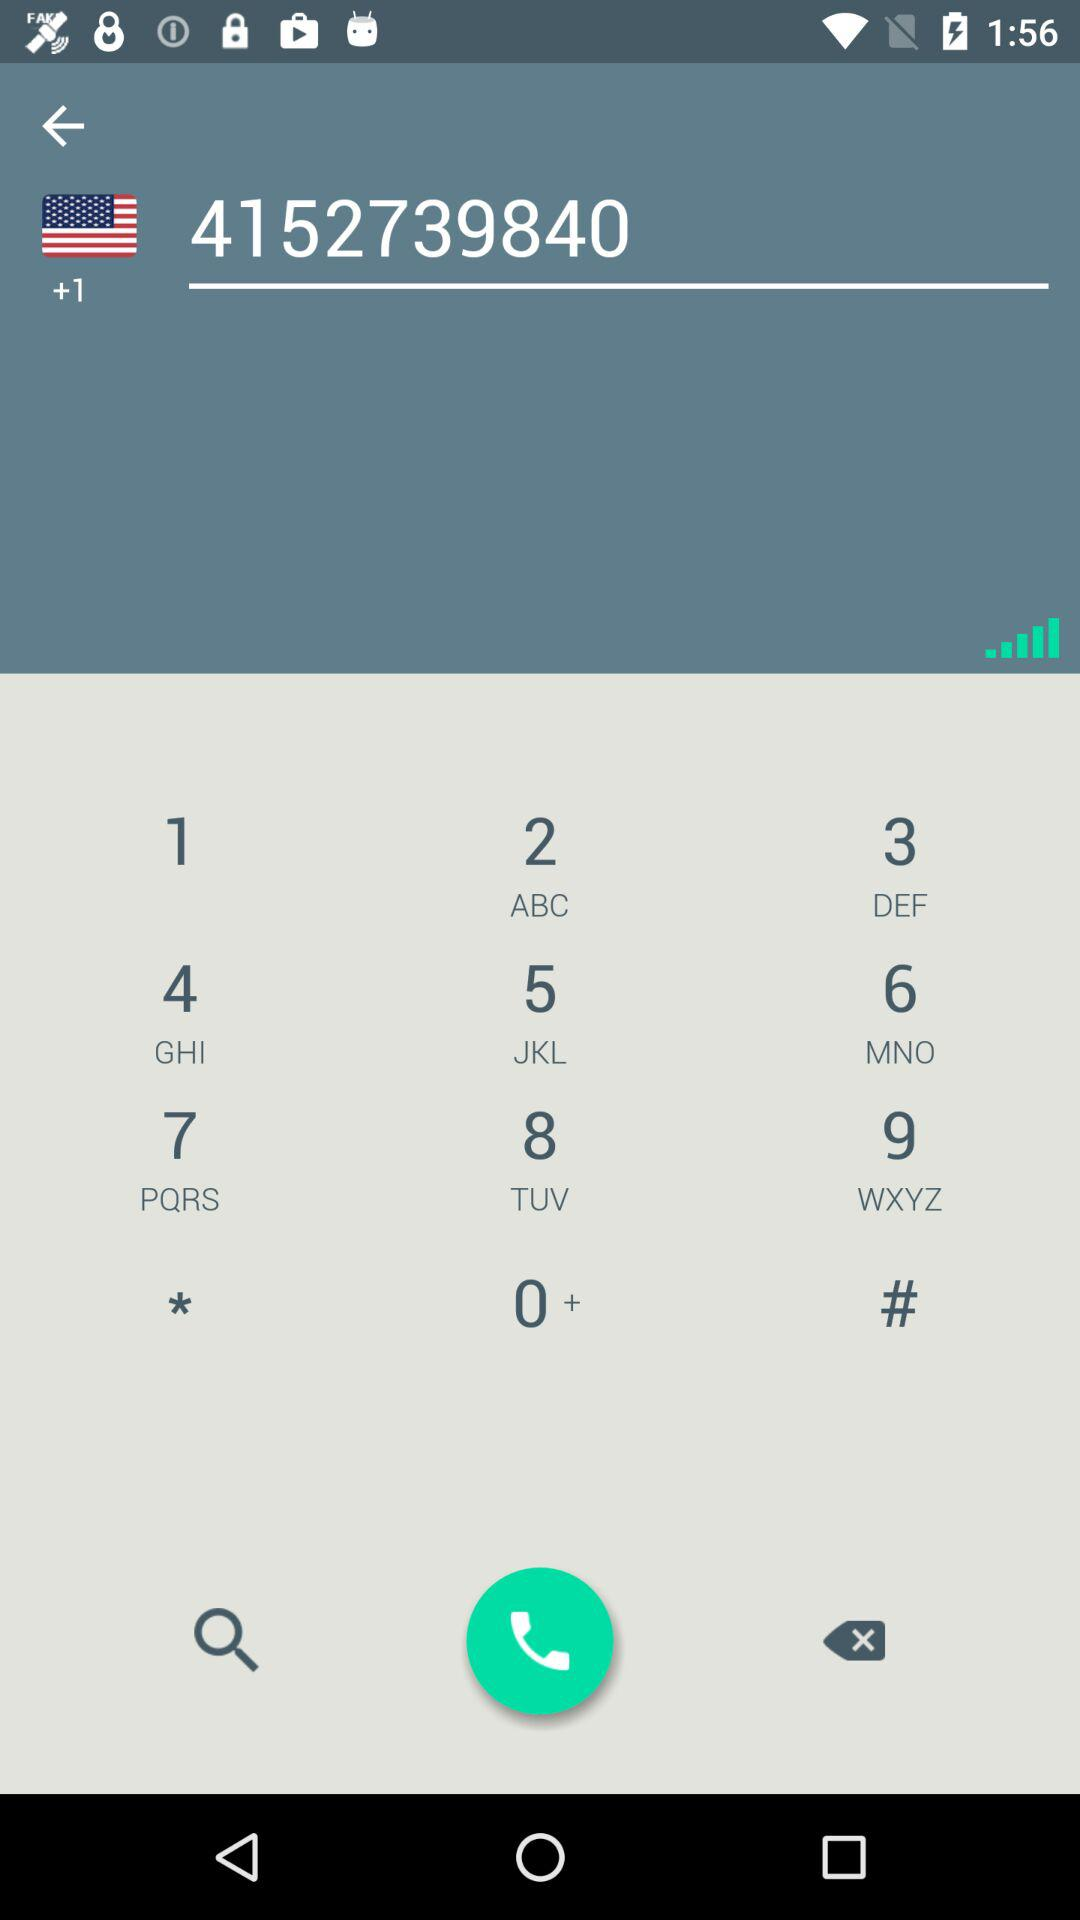What is the country code? The country code is +1. 